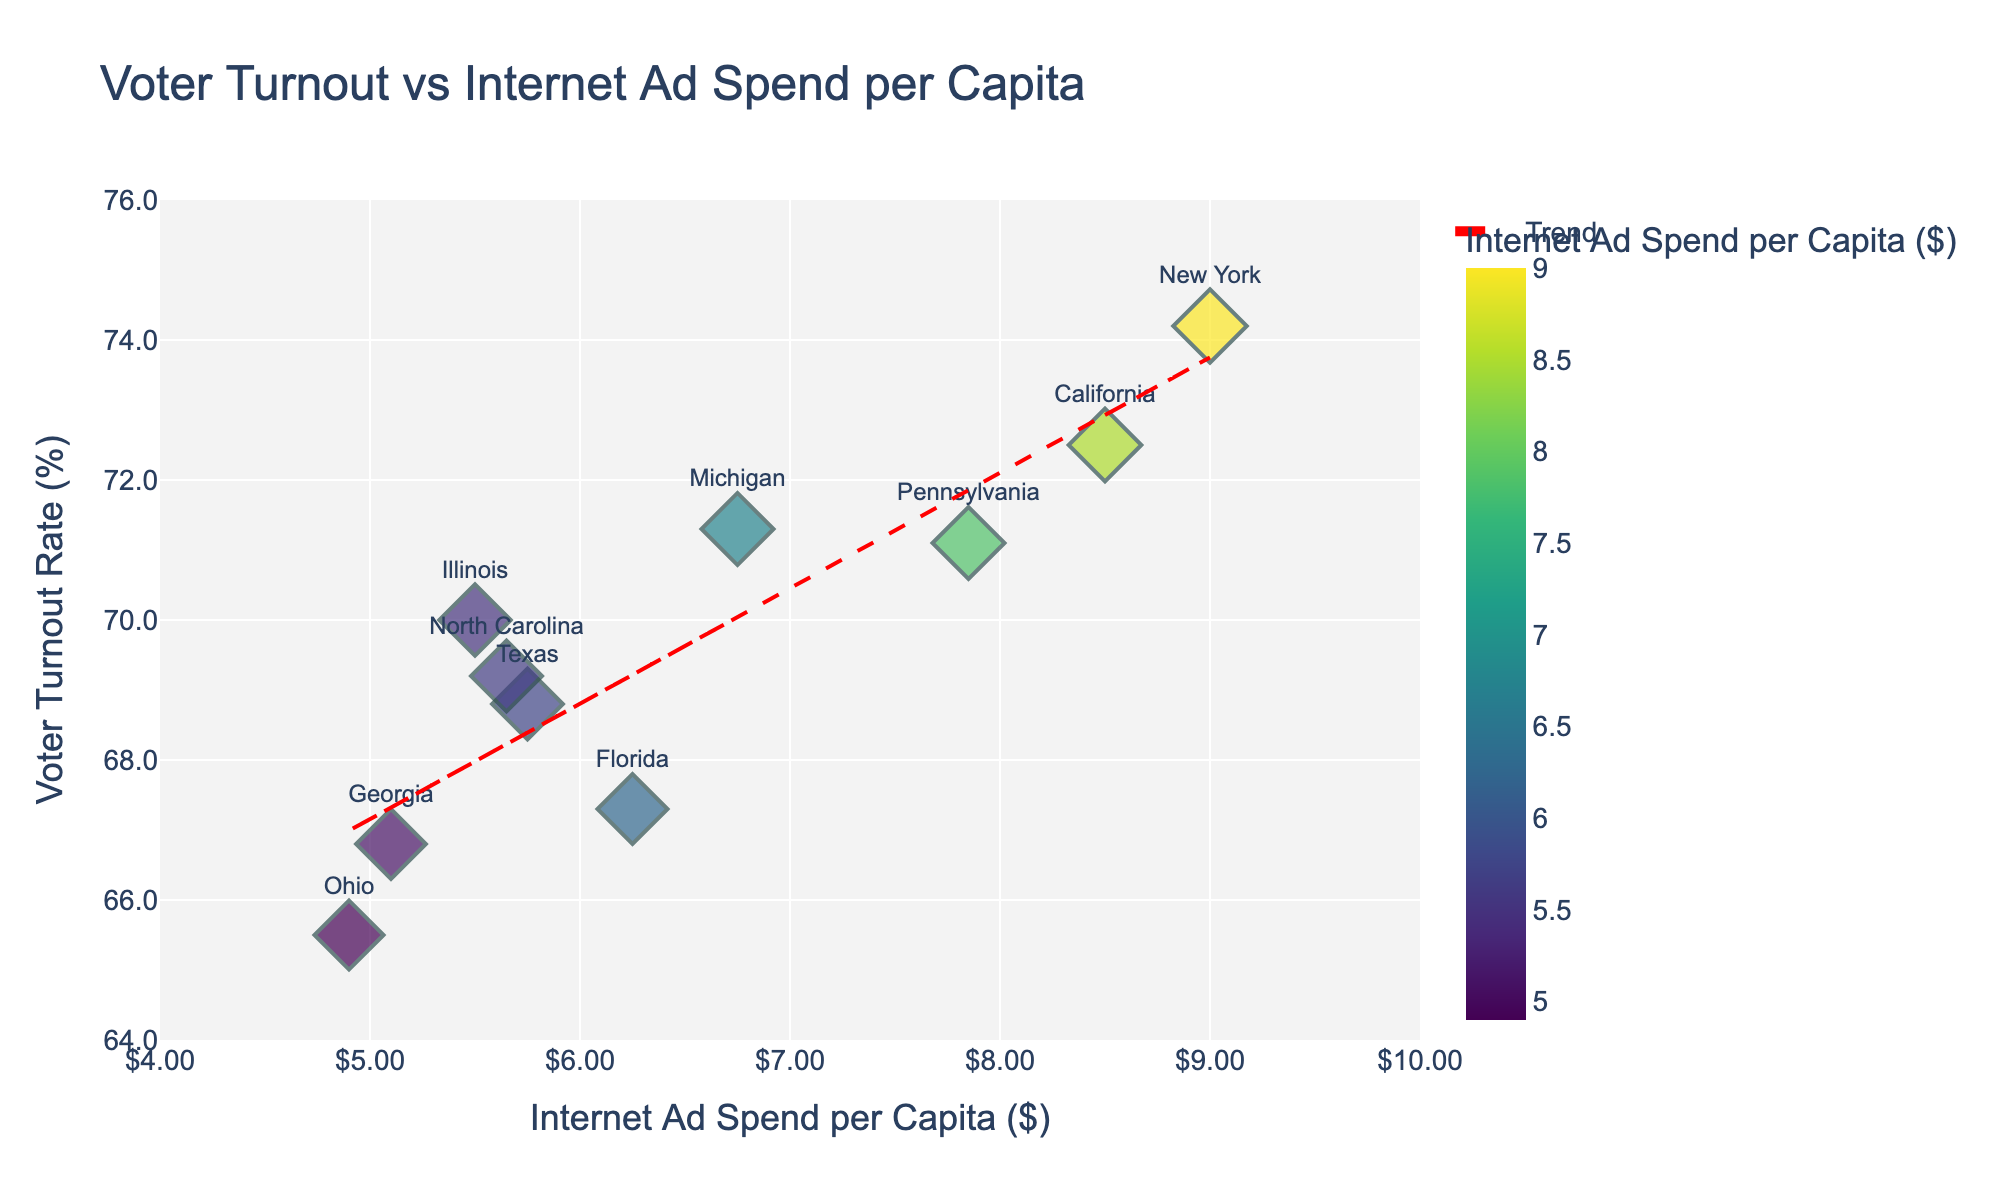What is the title of the scatter plot? The title of the scatter plot is displayed prominently at the top of the figure.
Answer: Voter Turnout vs Internet Ad Spend per Capita How many regions are represented in the scatter plot? Each region is represented by a unique data point, which can be counted on the plot.
Answer: 10 Which region has the highest internet ad spend per capita? By identifying the data point farthest to the right on the x-axis, we find the region with the highest internet ad spend per capita.
Answer: New York What's the range of voter turnout rates represented in the plot? The range for voter turnout rates can be observed from the lowest and highest points on the y-axis of the plot.
Answer: 65.5% to 74.2% Is there a trend line present in the scatter plot? If so, what is its direction? A red dashed trend line is present, and its direction (upward or downward slope) indicates the relationship between variables.
Answer: Yes, upward Which region has the lowest voter turnout rate? By finding the data point at the lowest position on the y-axis, we determine the region with the lowest voter turnout rate.
Answer: Ohio How does California's voter turnout rate compare to Florida's? By locating each region's data point and comparing their y-axis values, the relative voter turnout rates can be determined.
Answer: California is higher Calculate the average internet ad spend per capita of the regions. Sum the internet ad spend per capita for all regions and divide by the number of regions: (8.50 + 5.75 + 9.00 + 6.25 + 5.50 + 7.85 + 4.90 + 5.10 + 5.65 + 6.75) / 10.
Answer: $6.83 What is the voter turnout rate for Illinois? Find the data point corresponding to Illinois and note its y-axis position.
Answer: 70.0% Which region has a higher voter turnout rate: New York or Michigan? Compare the y-axis values for the data points representing New York and Michigan.
Answer: New York 